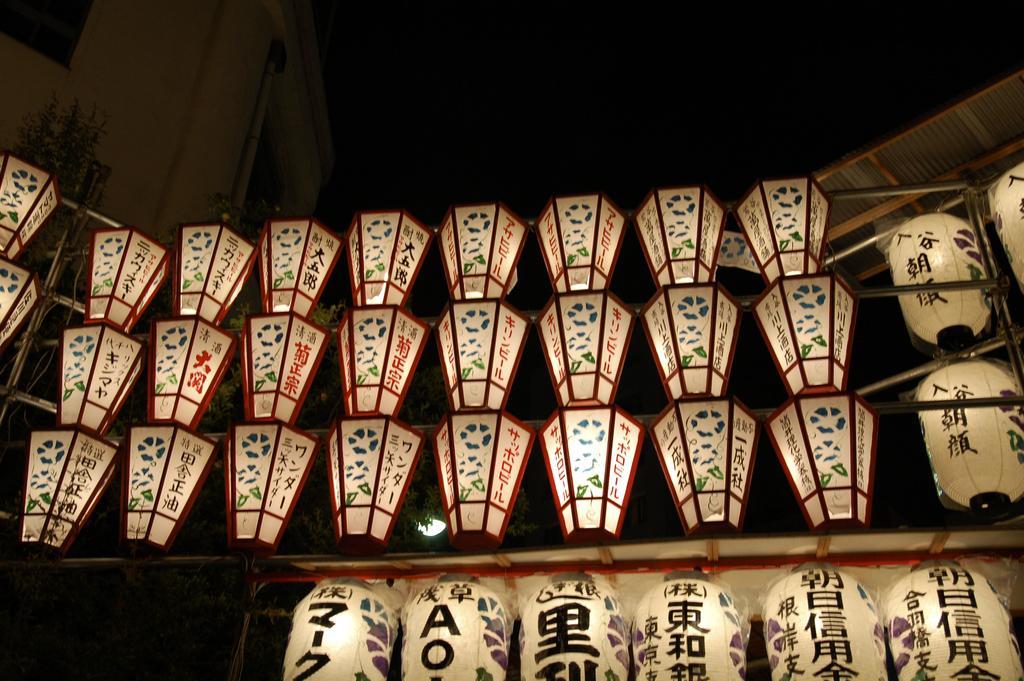Describe this image in one or two sentences. In the image there are many lights and above the lights there is a roof. 